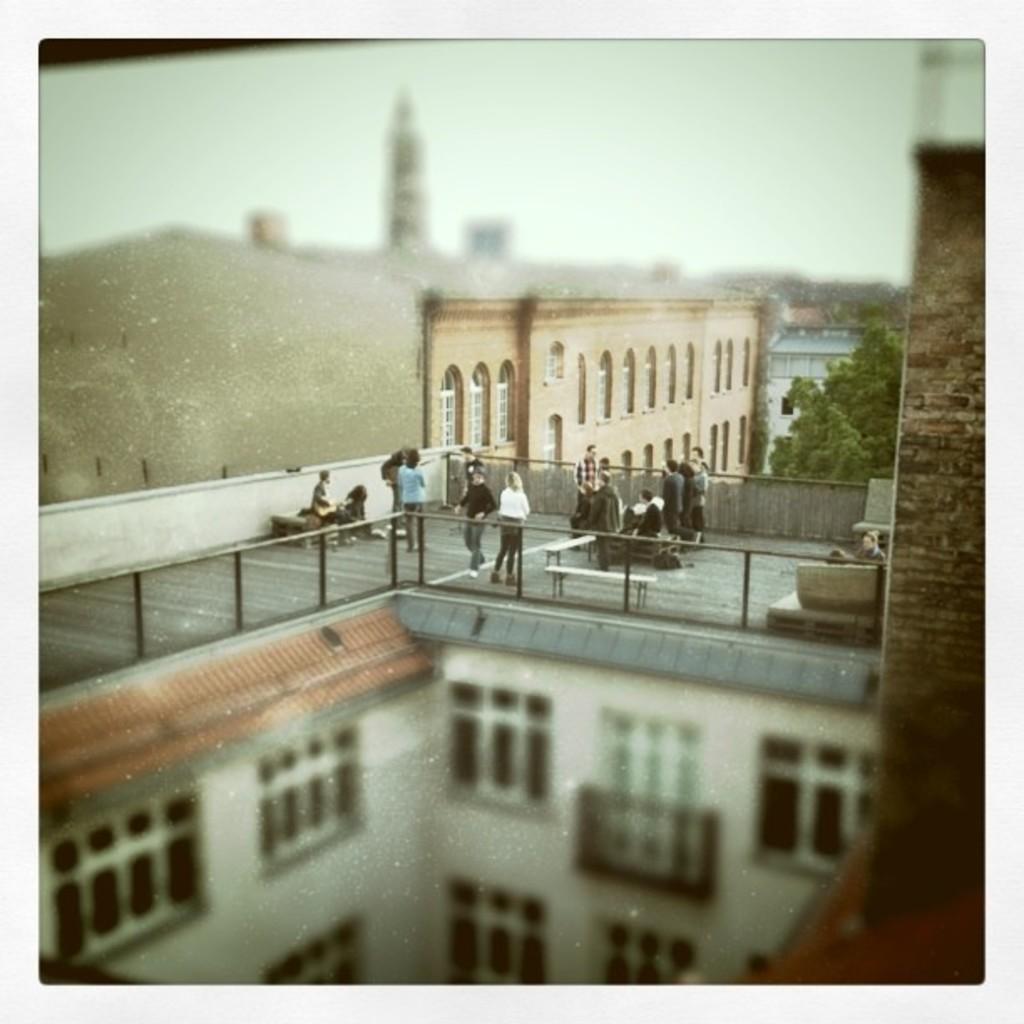How would you summarize this image in a sentence or two? In this image we can see buildings, pillars, sky, trees, persons standing on the floor and some are sitting on the benches. 